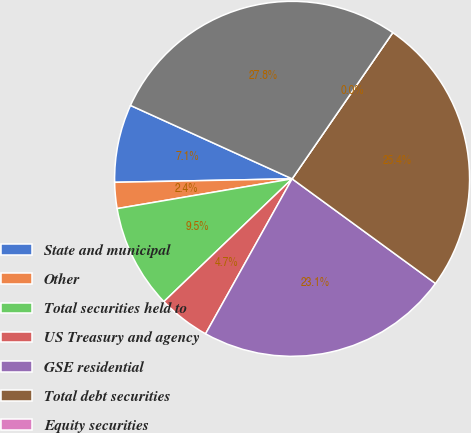Convert chart to OTSL. <chart><loc_0><loc_0><loc_500><loc_500><pie_chart><fcel>State and municipal<fcel>Other<fcel>Total securities held to<fcel>US Treasury and agency<fcel>GSE residential<fcel>Total debt securities<fcel>Equity securities<fcel>Total securities available for<nl><fcel>7.1%<fcel>2.37%<fcel>9.47%<fcel>4.74%<fcel>23.07%<fcel>25.44%<fcel>0.0%<fcel>27.81%<nl></chart> 